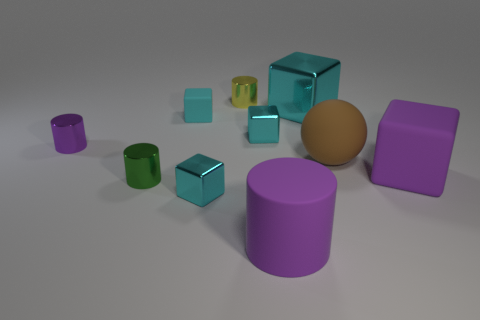What shape is the purple object that is in front of the big matte object to the right of the big ball?
Make the answer very short. Cylinder. What size is the cylinder on the right side of the small yellow thing?
Your response must be concise. Large. Does the large brown sphere have the same material as the large purple cylinder?
Your answer should be very brief. Yes. There is a tiny purple object that is the same material as the green cylinder; what shape is it?
Ensure brevity in your answer.  Cylinder. Are there any other things of the same color as the rubber cylinder?
Offer a very short reply. Yes. The large rubber thing left of the big cyan thing is what color?
Offer a very short reply. Purple. Is the color of the small metal object to the right of the yellow metal cylinder the same as the big metallic thing?
Provide a succinct answer. Yes. There is a green thing that is the same shape as the yellow object; what is it made of?
Offer a terse response. Metal. How many cyan shiny blocks are the same size as the sphere?
Offer a terse response. 1. The small yellow metallic object is what shape?
Offer a very short reply. Cylinder. 